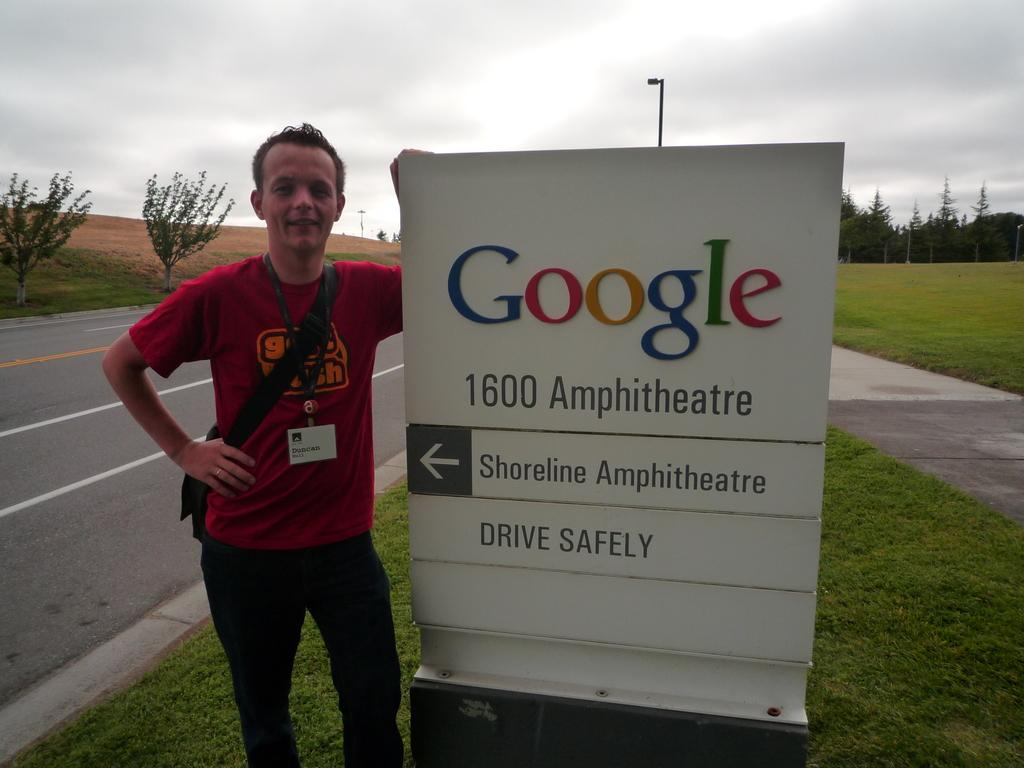<image>
Render a clear and concise summary of the photo. Duncan Hull stands next to a Google sign located at 1600 Amphitheatre.. 